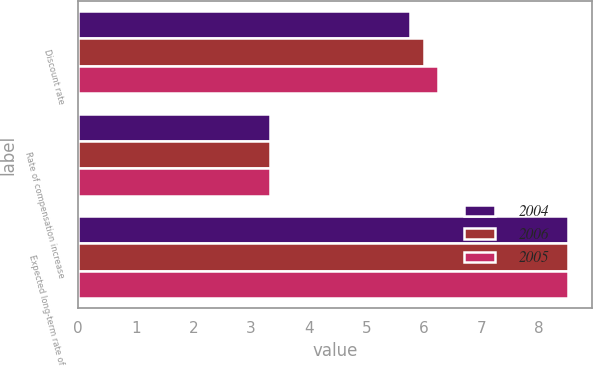Convert chart to OTSL. <chart><loc_0><loc_0><loc_500><loc_500><stacked_bar_chart><ecel><fcel>Discount rate<fcel>Rate of compensation increase<fcel>Expected long-term rate of<nl><fcel>2004<fcel>5.75<fcel>3.33<fcel>8.5<nl><fcel>2006<fcel>6<fcel>3.33<fcel>8.5<nl><fcel>2005<fcel>6.25<fcel>3.33<fcel>8.5<nl></chart> 